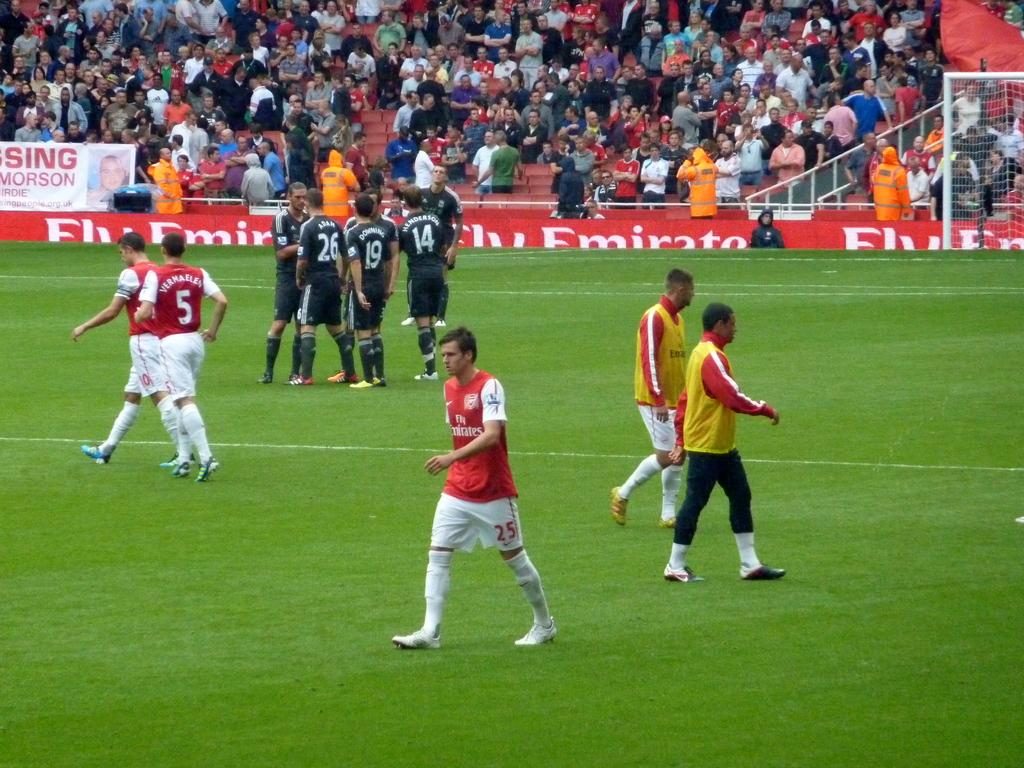Provide a one-sentence caption for the provided image. A soccer field advertisement encourages people to Fly Emirates. 